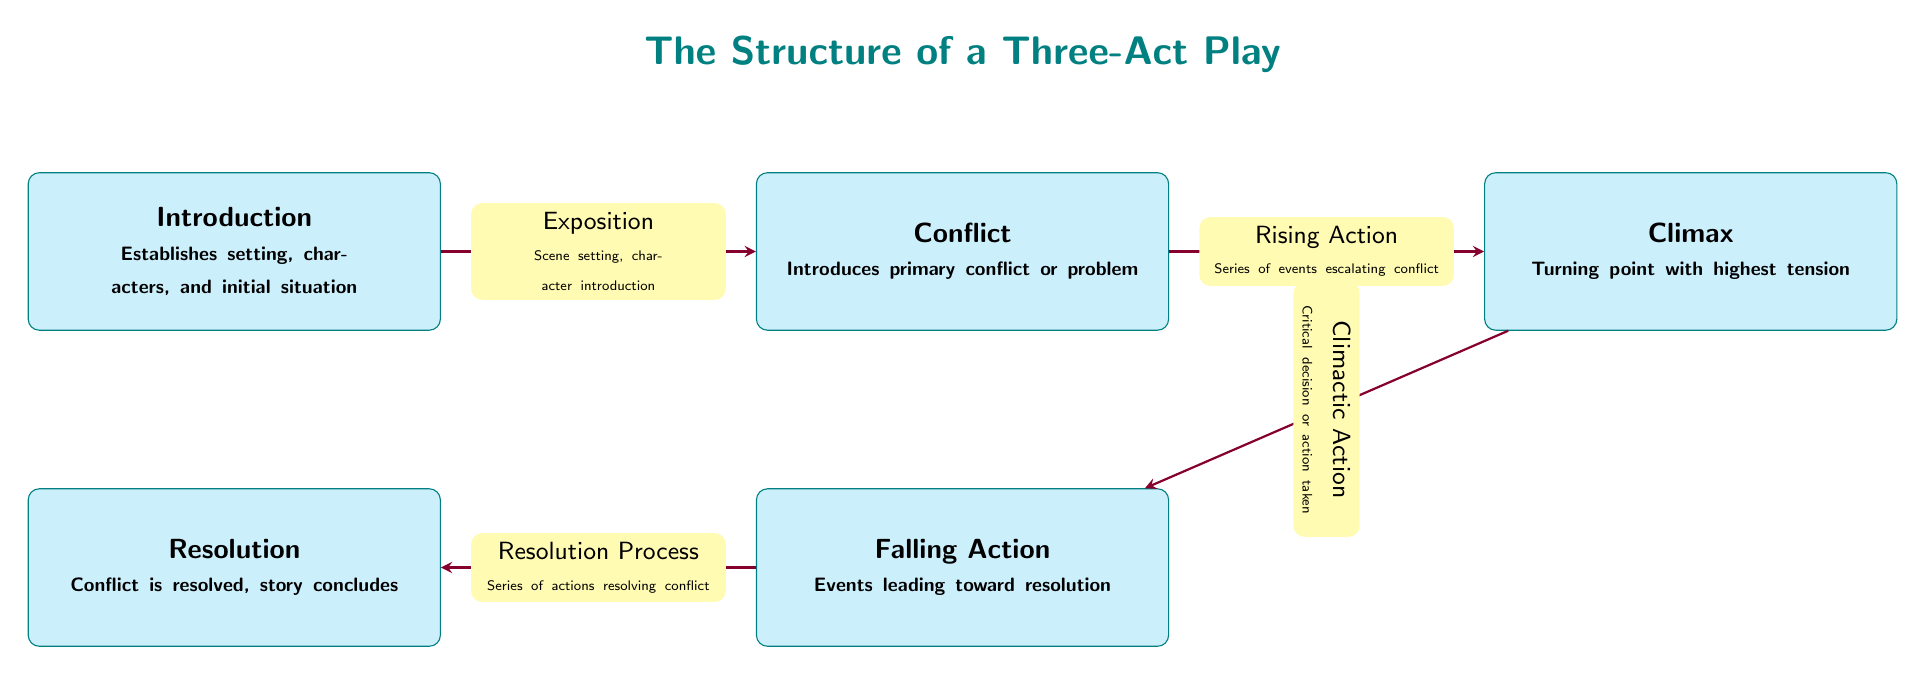What are the five phases of a three-act play? Referring to the diagram, the five phases listed are Introduction, Conflict, Climax, Falling Action, and Resolution.
Answer: Introduction, Conflict, Climax, Falling Action, Resolution What does the arrow from Introduction to Conflict represent? The arrow between these nodes is labeled "Exposition," indicating the process of scene setting and character introduction that leads from the Introduction to the Conflict.
Answer: Exposition Which phase has the highest tension? The Climax phase is described in the diagram as the turning point with the highest tension.
Answer: Climax What is the purpose of the Falling Action phase? The description below the Falling Action node states it represents the events leading toward resolution, meaning it serves to transition from the climax towards resolving the conflict.
Answer: Events leading toward resolution What is the function of the Resolution phase in the diagram? The Resolution phase is described as where the conflict is resolved and the story concludes, serving the purpose of finalizing the narrative.
Answer: Conflict is resolved, story concludes What type of action is indicated by the arrow from Climax to Falling Action? The label on the arrow indicates "Climactic Action," which represents the critical decision or action taken at the peak of the narrative tension.
Answer: Climactic Action How many arrows are displayed in the diagram? By counting the arrows connecting the nodes, there are four arrows indicating the relationships between each of the phases.
Answer: Four Which phase follows the Climax in the flow of the diagram? The diagram shows that the Falling Action phase comes directly after the Climax, indicating the narrative’s transition towards resolution.
Answer: Falling Action What leads to the Resolution phase? The diagram indicates that the Falling Action leads to the Resolution phase, represented by the labeled arrow "Resolution Process," which consists of a series of actions resolving the conflict.
Answer: Falling Action 